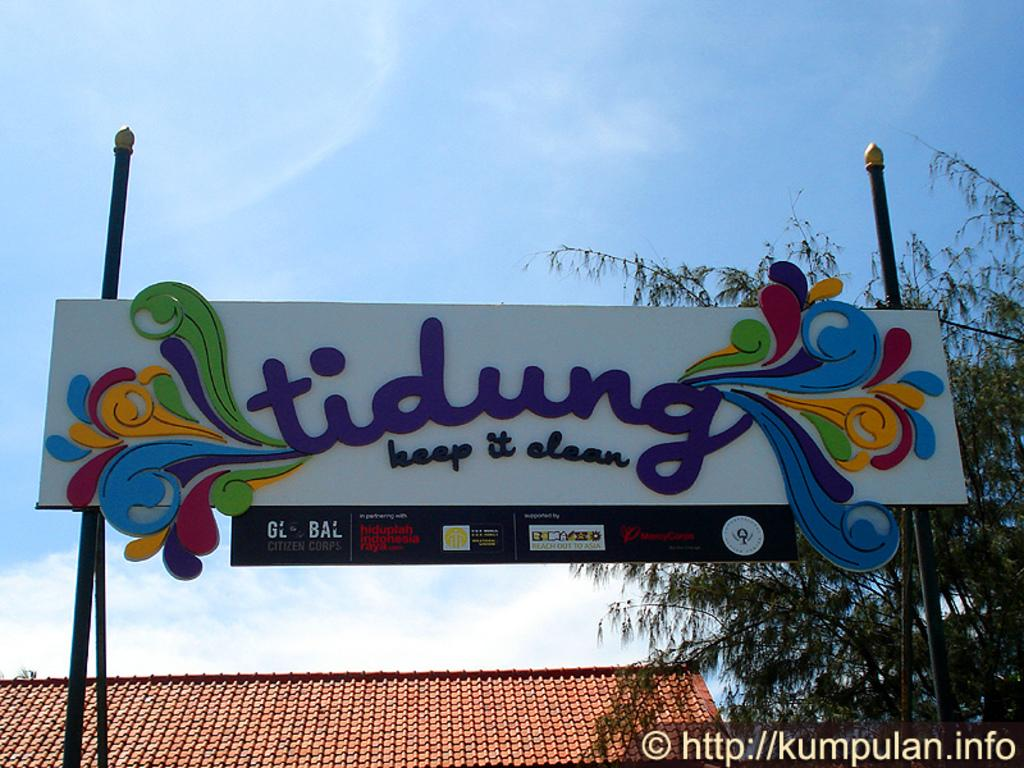Provide a one-sentence caption for the provided image. A sign encouraging people to keep things clean. 